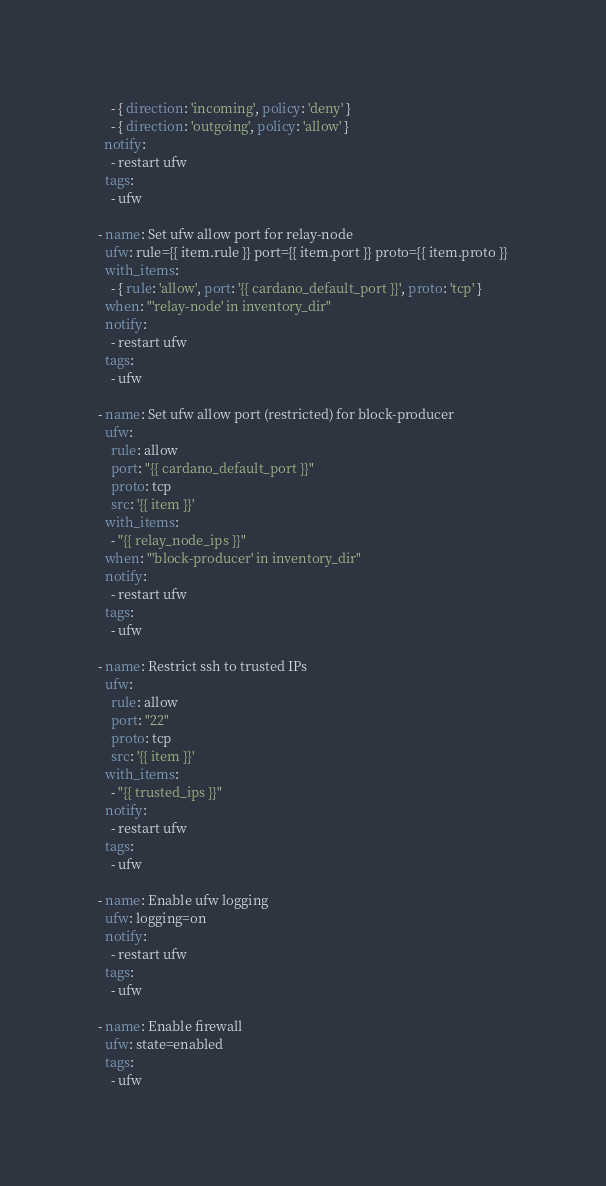Convert code to text. <code><loc_0><loc_0><loc_500><loc_500><_YAML_>    - { direction: 'incoming', policy: 'deny' }
    - { direction: 'outgoing', policy: 'allow' }
  notify:
    - restart ufw
  tags:
    - ufw

- name: Set ufw allow port for relay-node
  ufw: rule={{ item.rule }} port={{ item.port }} proto={{ item.proto }}
  with_items:
    - { rule: 'allow', port: '{{ cardano_default_port }}', proto: 'tcp' }
  when: "'relay-node' in inventory_dir"
  notify:
    - restart ufw
  tags:
    - ufw

- name: Set ufw allow port (restricted) for block-producer
  ufw:
    rule: allow
    port: "{{ cardano_default_port }}"
    proto: tcp
    src: '{{ item }}'
  with_items:
    - "{{ relay_node_ips }}"
  when: "'block-producer' in inventory_dir"
  notify:
    - restart ufw
  tags:
    - ufw

- name: Restrict ssh to trusted IPs
  ufw:
    rule: allow
    port: "22"
    proto: tcp
    src: '{{ item }}'
  with_items:
    - "{{ trusted_ips }}"
  notify:
    - restart ufw
  tags:
    - ufw

- name: Enable ufw logging
  ufw: logging=on
  notify:
    - restart ufw
  tags:
    - ufw

- name: Enable firewall
  ufw: state=enabled
  tags:
    - ufw

</code> 